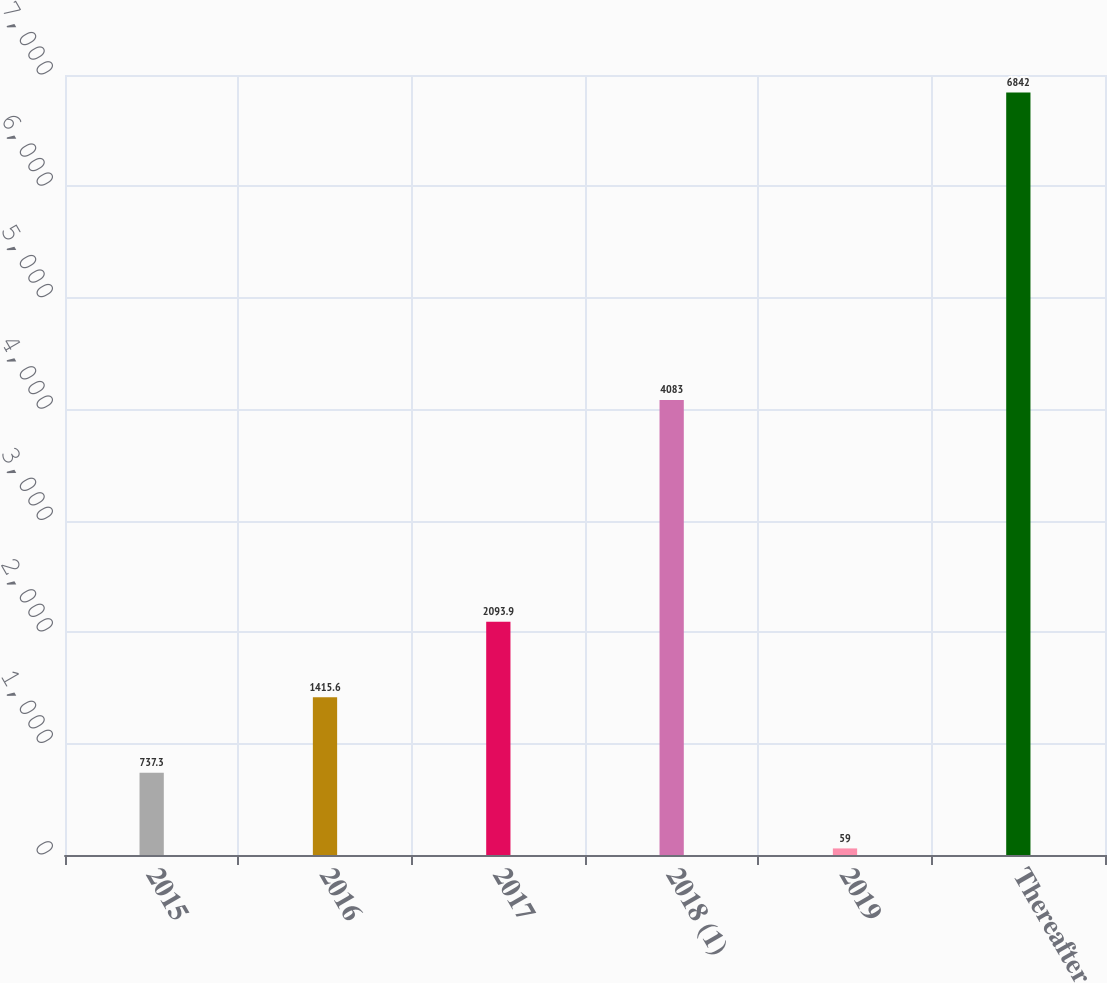Convert chart to OTSL. <chart><loc_0><loc_0><loc_500><loc_500><bar_chart><fcel>2015<fcel>2016<fcel>2017<fcel>2018 (1)<fcel>2019<fcel>Thereafter<nl><fcel>737.3<fcel>1415.6<fcel>2093.9<fcel>4083<fcel>59<fcel>6842<nl></chart> 